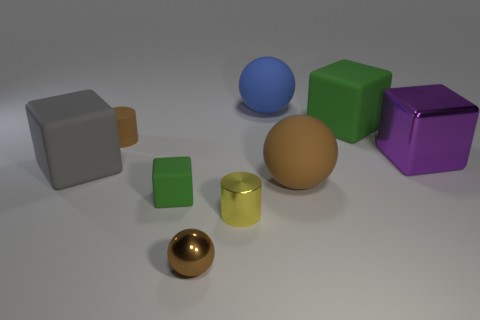Subtract all brown metallic spheres. How many spheres are left? 2 Subtract all brown blocks. How many brown spheres are left? 2 Subtract 2 cubes. How many cubes are left? 2 Subtract all gray cubes. How many cubes are left? 3 Subtract all yellow blocks. Subtract all brown balls. How many blocks are left? 4 Subtract all spheres. How many objects are left? 6 Subtract all tiny brown things. Subtract all shiny blocks. How many objects are left? 6 Add 5 gray rubber blocks. How many gray rubber blocks are left? 6 Add 9 green matte balls. How many green matte balls exist? 9 Subtract 0 gray cylinders. How many objects are left? 9 